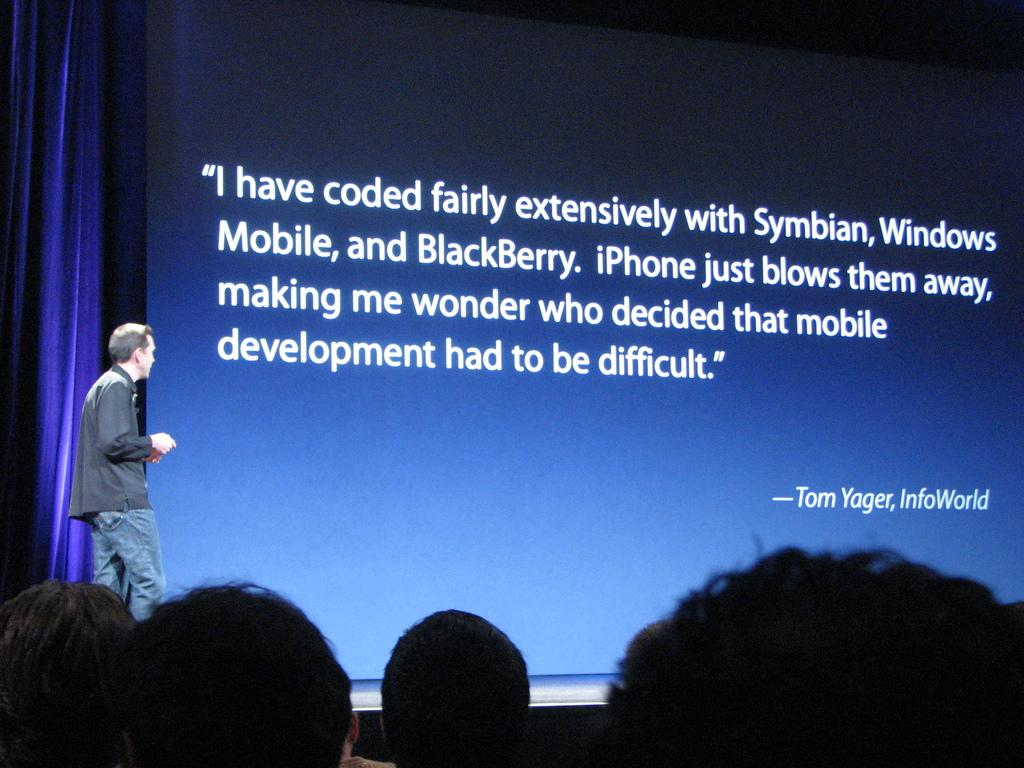Who can be seen in the image? There are people in the image. Can you describe the position of the man in relation to the other people? There is a man in front of the people. What is in front of the people besides the man? There is a screen and a curtain in front of the people. What type of apple is being served by the porter in the image? There is no apple or porter present in the image. Where did the birth of the first child in the image take place? There is no reference to a birth or a child in the image. 